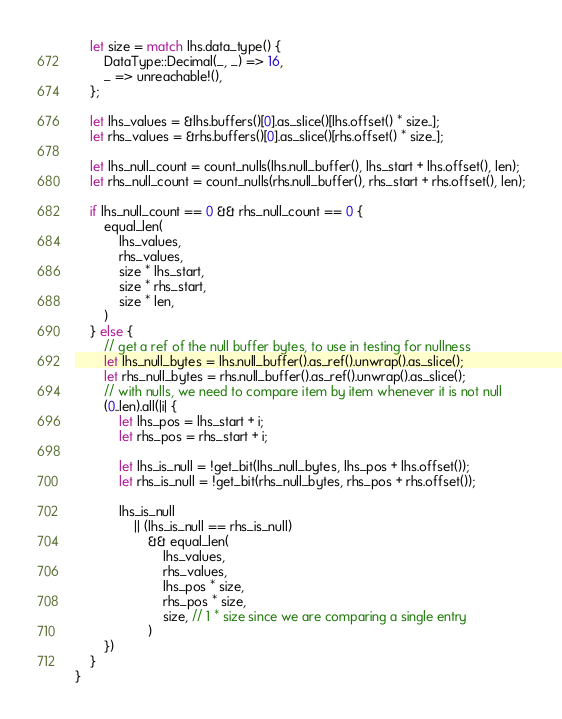<code> <loc_0><loc_0><loc_500><loc_500><_Rust_>    let size = match lhs.data_type() {
        DataType::Decimal(_, _) => 16,
        _ => unreachable!(),
    };

    let lhs_values = &lhs.buffers()[0].as_slice()[lhs.offset() * size..];
    let rhs_values = &rhs.buffers()[0].as_slice()[rhs.offset() * size..];

    let lhs_null_count = count_nulls(lhs.null_buffer(), lhs_start + lhs.offset(), len);
    let rhs_null_count = count_nulls(rhs.null_buffer(), rhs_start + rhs.offset(), len);

    if lhs_null_count == 0 && rhs_null_count == 0 {
        equal_len(
            lhs_values,
            rhs_values,
            size * lhs_start,
            size * rhs_start,
            size * len,
        )
    } else {
        // get a ref of the null buffer bytes, to use in testing for nullness
        let lhs_null_bytes = lhs.null_buffer().as_ref().unwrap().as_slice();
        let rhs_null_bytes = rhs.null_buffer().as_ref().unwrap().as_slice();
        // with nulls, we need to compare item by item whenever it is not null
        (0..len).all(|i| {
            let lhs_pos = lhs_start + i;
            let rhs_pos = rhs_start + i;

            let lhs_is_null = !get_bit(lhs_null_bytes, lhs_pos + lhs.offset());
            let rhs_is_null = !get_bit(rhs_null_bytes, rhs_pos + rhs.offset());

            lhs_is_null
                || (lhs_is_null == rhs_is_null)
                    && equal_len(
                        lhs_values,
                        rhs_values,
                        lhs_pos * size,
                        rhs_pos * size,
                        size, // 1 * size since we are comparing a single entry
                    )
        })
    }
}
</code> 